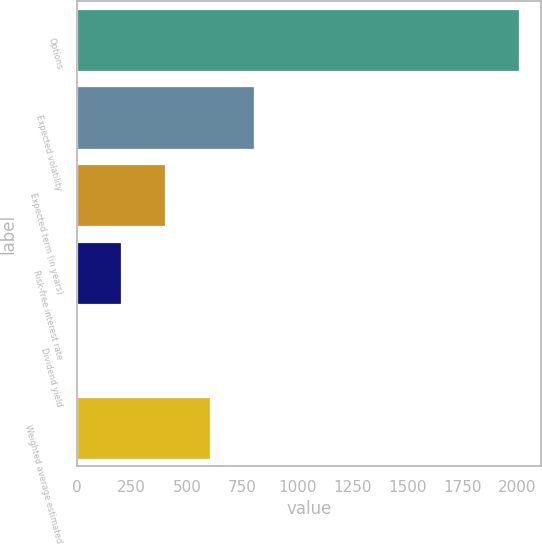Convert chart. <chart><loc_0><loc_0><loc_500><loc_500><bar_chart><fcel>Options<fcel>Expected volatility<fcel>Expected term (in years)<fcel>Risk-free interest rate<fcel>Dividend yield<fcel>Weighted average estimated<nl><fcel>2007<fcel>803.56<fcel>402.42<fcel>201.85<fcel>1.28<fcel>602.99<nl></chart> 